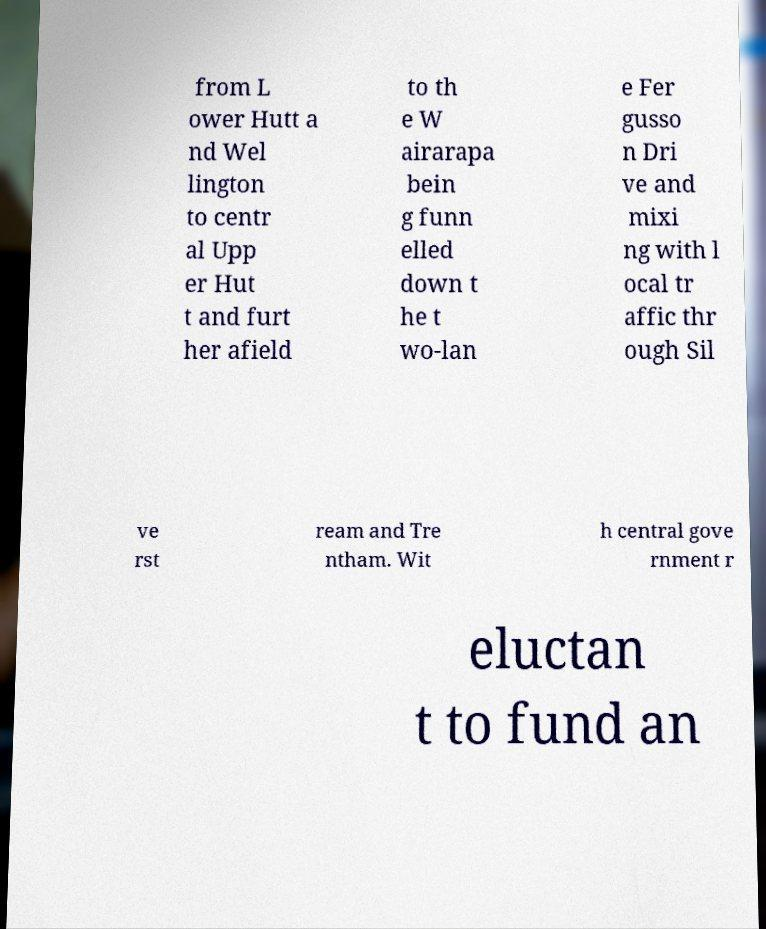Can you read and provide the text displayed in the image?This photo seems to have some interesting text. Can you extract and type it out for me? from L ower Hutt a nd Wel lington to centr al Upp er Hut t and furt her afield to th e W airarapa bein g funn elled down t he t wo-lan e Fer gusso n Dri ve and mixi ng with l ocal tr affic thr ough Sil ve rst ream and Tre ntham. Wit h central gove rnment r eluctan t to fund an 